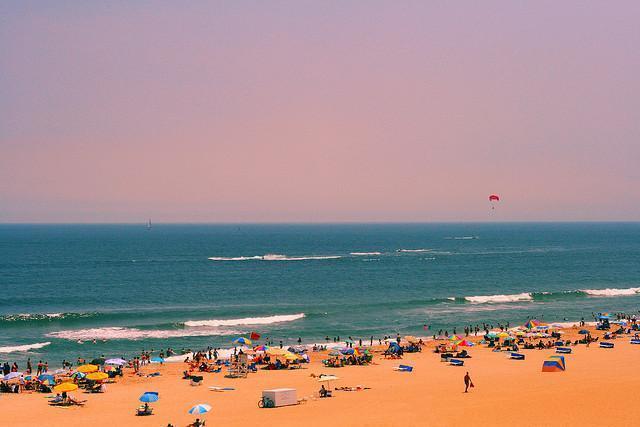How many tires are visible in between the two greyhound dog logos?
Give a very brief answer. 0. 